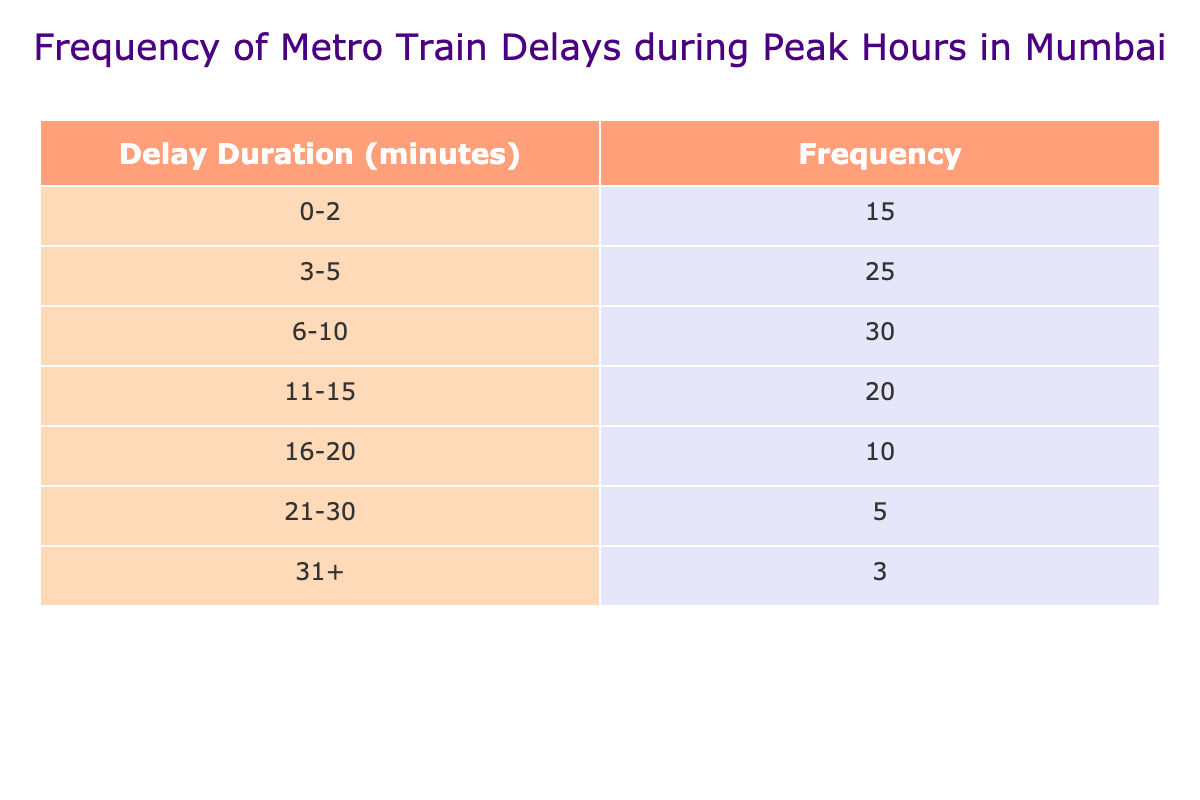What is the frequency of delays lasting 3-5 minutes? The table shows that the frequency of delays lasting 3-5 minutes is 25.
Answer: 25 What is the total frequency of delays that are 10 minutes or less? To find the total frequency of delays that are 10 minutes or less, we add the frequencies of the relevant ranges: 15 (for 0-2) + 25 (for 3-5) + 30 (for 6-10) = 70.
Answer: 70 Is it true that the frequency of delays longer than 20 minutes is less than the frequency of delays longer than 10 minutes? The frequency of delays longer than 20 minutes is 5 (21-30) + 3 (31+) = 8. The frequency for delays longer than 10 minutes is 20 (for 11-15) + 10 (for 16-20) + 5 (for 21-30) + 3 (for 31+) = 38. Since 8 is less than 38, the statement is true.
Answer: Yes What is the median delay range of the frequencies listed in the table? To find the median range, we first calculate the cumulative frequency: 15 (0-2) + 25 (3-5) + 30 (6-10) + 20 (11-15) = 90. The median is the 45th value in an ordered list of frequencies. The cumulative frequencies lead to the intervals: 0-2 has 15, 3-5 has 40 (15+25), and 6-10 reaches 70. The 45th value falls in the 6-10 range, making it the median.
Answer: 6-10 What is the frequency of delays between 11 and 20 minutes? The frequency of delays from the ranges between 11-15 and 16-20 is: 20 (for 11-15) + 10 (for 16-20) = 30.
Answer: 30 What percentage of delays are longer than 10 minutes? First, we determine the total frequency, which is 100 (by adding all frequencies). Then, the frequency of delays longer than 10 minutes is 20 (11-15) + 10 (16-20) + 5 (21-30) + 3 (31+) = 38. The percentage is calculated as (38/100) * 100 = 38%.
Answer: 38% How many delays last 6 minutes or longer? To find the total delays lasting 6 minutes or longer, we consider the ranges 6-10, 11-15, 16-20, 21-30, and 31+. Their frequencies are: 30 + 20 + 10 + 5 + 3 = 68.
Answer: 68 What is the difference in frequency between the longest and shortest delay ranges? The shortest delay range (0-2) has a frequency of 15, and the longest delay range (31+) has a frequency of 3. The difference is 15 - 3 = 12.
Answer: 12 